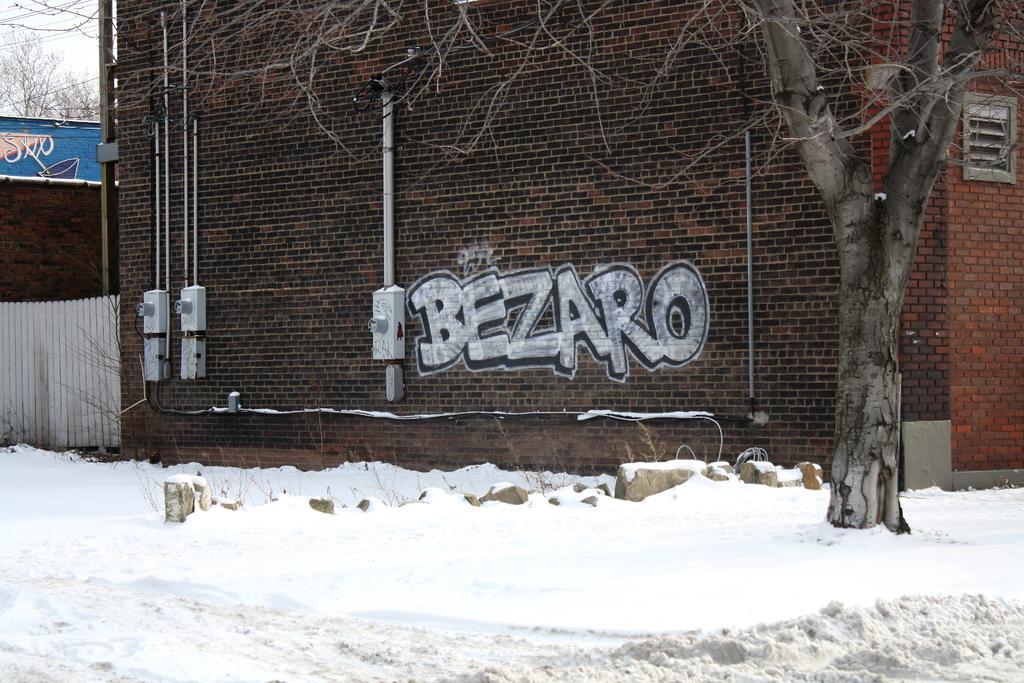Can you describe this image briefly? In this image we can see snow on the ground. There are stones. And there is a tree. In the back there is a building with brick walls. On the wall there are pipes and text. And there is a fencing. On the left side there is a board with text. In the back there is sky and trees. 